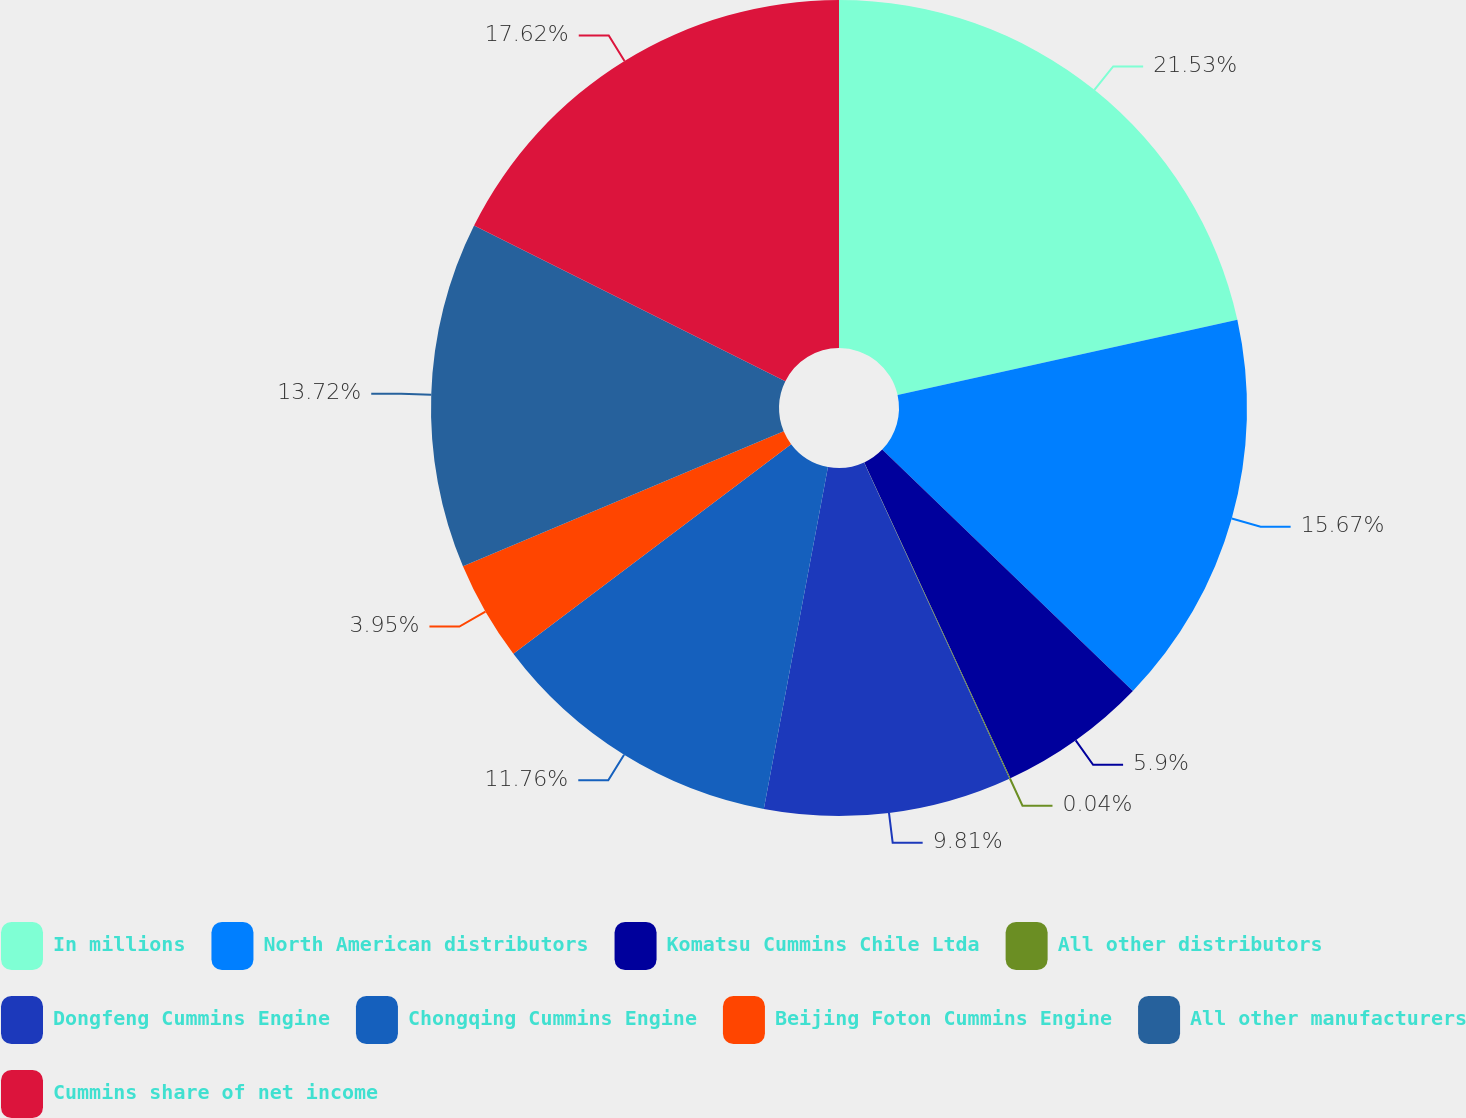<chart> <loc_0><loc_0><loc_500><loc_500><pie_chart><fcel>In millions<fcel>North American distributors<fcel>Komatsu Cummins Chile Ltda<fcel>All other distributors<fcel>Dongfeng Cummins Engine<fcel>Chongqing Cummins Engine<fcel>Beijing Foton Cummins Engine<fcel>All other manufacturers<fcel>Cummins share of net income<nl><fcel>21.53%<fcel>15.67%<fcel>5.9%<fcel>0.04%<fcel>9.81%<fcel>11.76%<fcel>3.95%<fcel>13.72%<fcel>17.62%<nl></chart> 